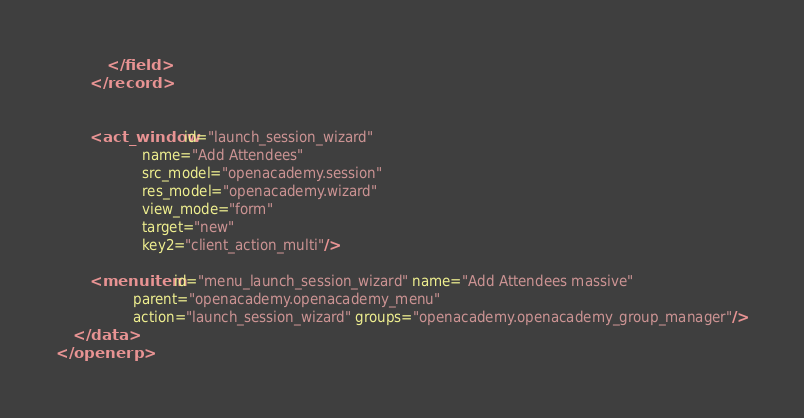Convert code to text. <code><loc_0><loc_0><loc_500><loc_500><_XML_>            </field>
        </record>


        <act_window id="launch_session_wizard"
                    name="Add Attendees"
                    src_model="openacademy.session"
                    res_model="openacademy.wizard"
                    view_mode="form"
                    target="new"
                    key2="client_action_multi"/>
        
        <menuitem id="menu_launch_session_wizard" name="Add Attendees massive"
                  parent="openacademy.openacademy_menu"
                  action="launch_session_wizard" groups="openacademy.openacademy_group_manager"/>
    </data>
</openerp>
</code> 